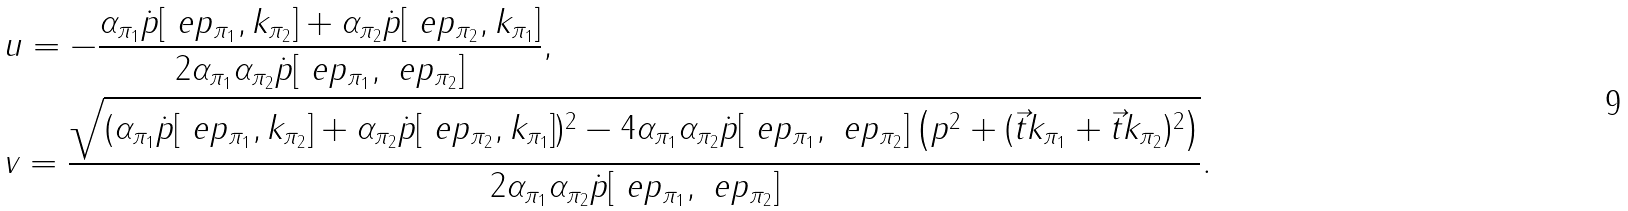Convert formula to latex. <formula><loc_0><loc_0><loc_500><loc_500>& u = - \frac { \alpha _ { \pi _ { 1 } } \dot { p } [ \ e p _ { \pi _ { 1 } } , k _ { \pi _ { 2 } } ] + \alpha _ { \pi _ { 2 } } \dot { p } [ \ e p _ { \pi _ { 2 } } , k _ { \pi _ { 1 } } ] } { 2 \alpha _ { \pi _ { 1 } } \alpha _ { \pi _ { 2 } } \dot { p } [ \ e p _ { \pi _ { 1 } } , \ e p _ { \pi _ { 2 } } ] } , \\ & v = \frac { \sqrt { ( \alpha _ { \pi _ { 1 } } \dot { p } [ \ e p _ { \pi _ { 1 } } , k _ { \pi _ { 2 } } ] + \alpha _ { \pi _ { 2 } } \dot { p } [ \ e p _ { \pi _ { 2 } } , k _ { \pi _ { 1 } } ] ) ^ { 2 } - 4 \alpha _ { \pi _ { 1 } } \alpha _ { \pi _ { 2 } } \dot { p } [ \ e p _ { \pi _ { 1 } } , \ e p _ { \pi _ { 2 } } ] \left ( p ^ { 2 } + ( \vec { t } { k _ { \pi _ { 1 } } } + \vec { t } { k _ { \pi _ { 2 } } } ) ^ { 2 } \right ) } } { 2 \alpha _ { \pi _ { 1 } } \alpha _ { \pi _ { 2 } } \dot { p } [ \ e p _ { \pi _ { 1 } } , \ e p _ { \pi _ { 2 } } ] } .</formula> 